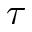Convert formula to latex. <formula><loc_0><loc_0><loc_500><loc_500>\tau</formula> 